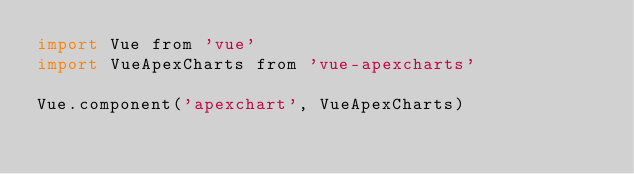<code> <loc_0><loc_0><loc_500><loc_500><_JavaScript_>import Vue from 'vue'
import VueApexCharts from 'vue-apexcharts'

Vue.component('apexchart', VueApexCharts)</code> 